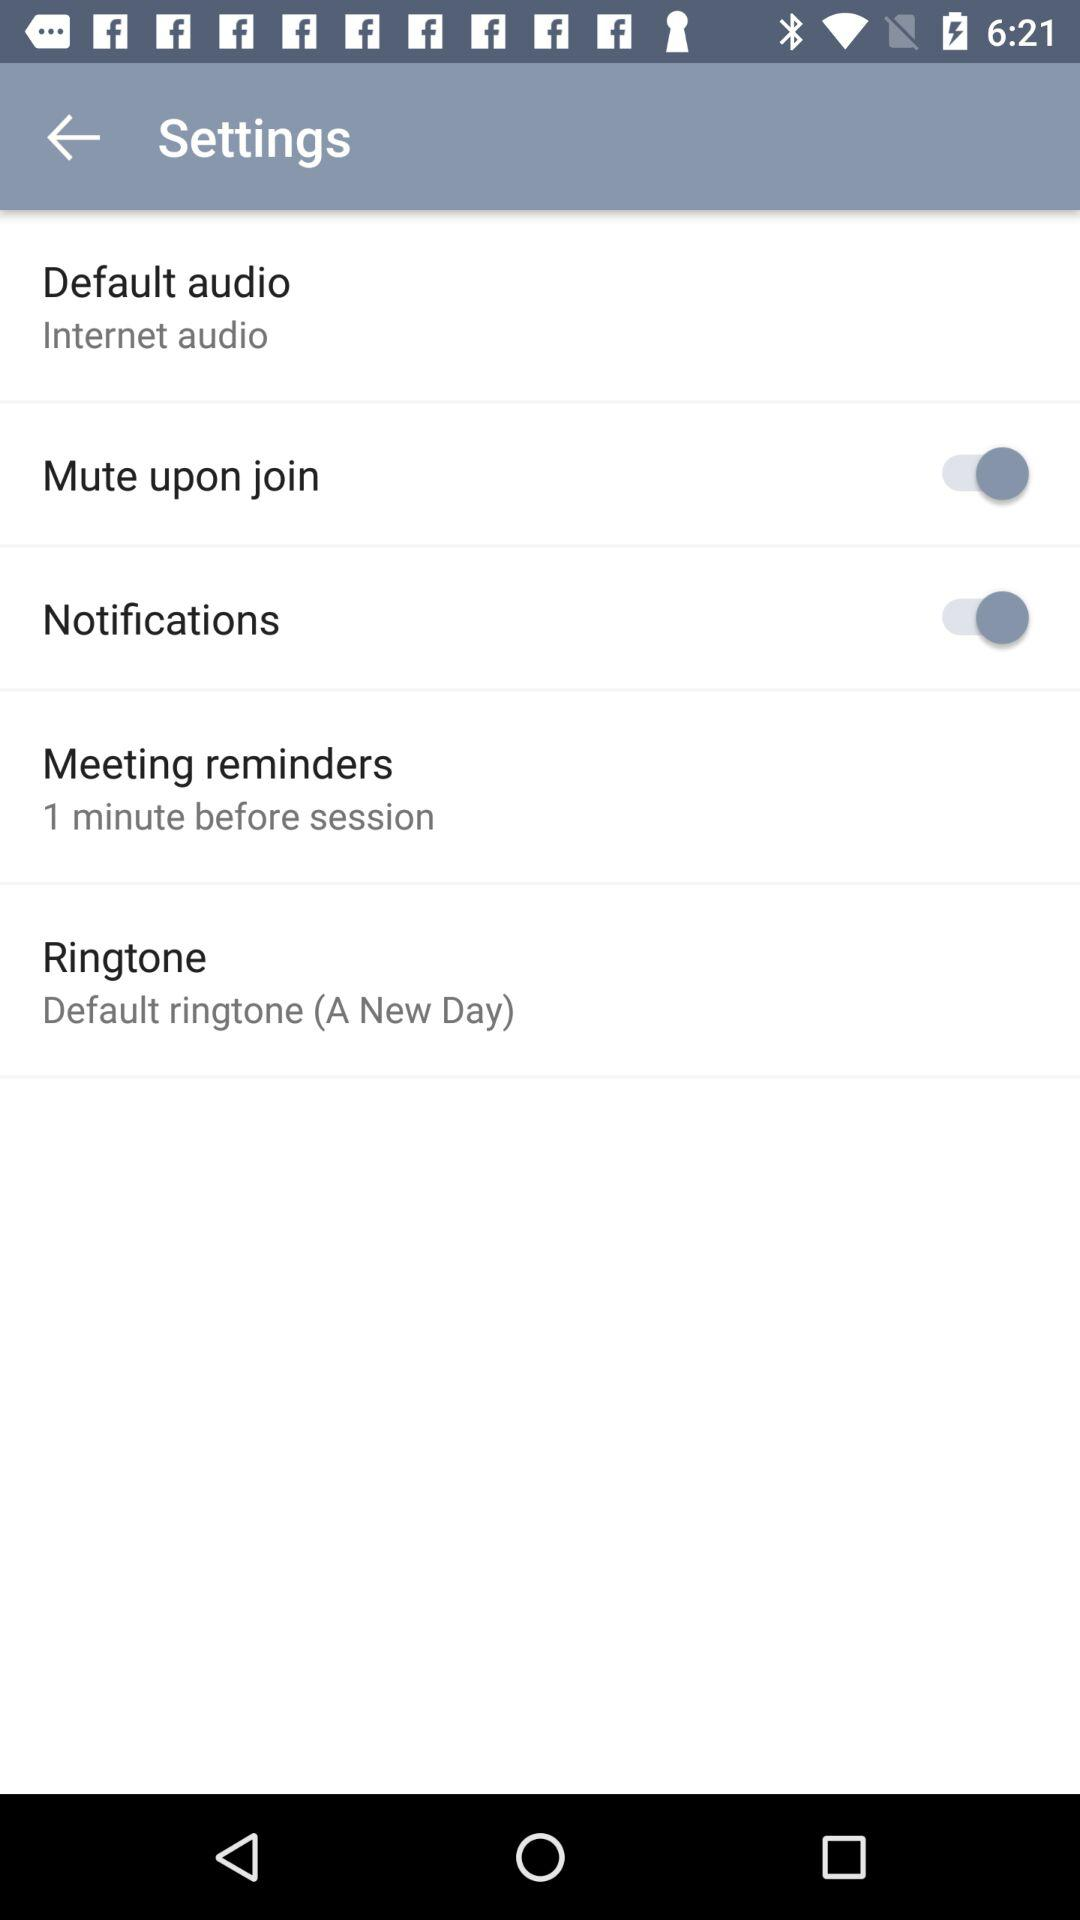What is the status of the notifications setting? The status is on. 